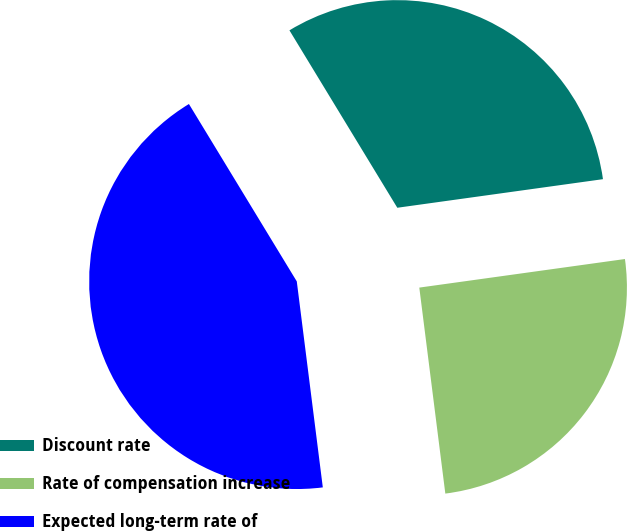<chart> <loc_0><loc_0><loc_500><loc_500><pie_chart><fcel>Discount rate<fcel>Rate of compensation increase<fcel>Expected long-term rate of<nl><fcel>31.5%<fcel>25.2%<fcel>43.31%<nl></chart> 